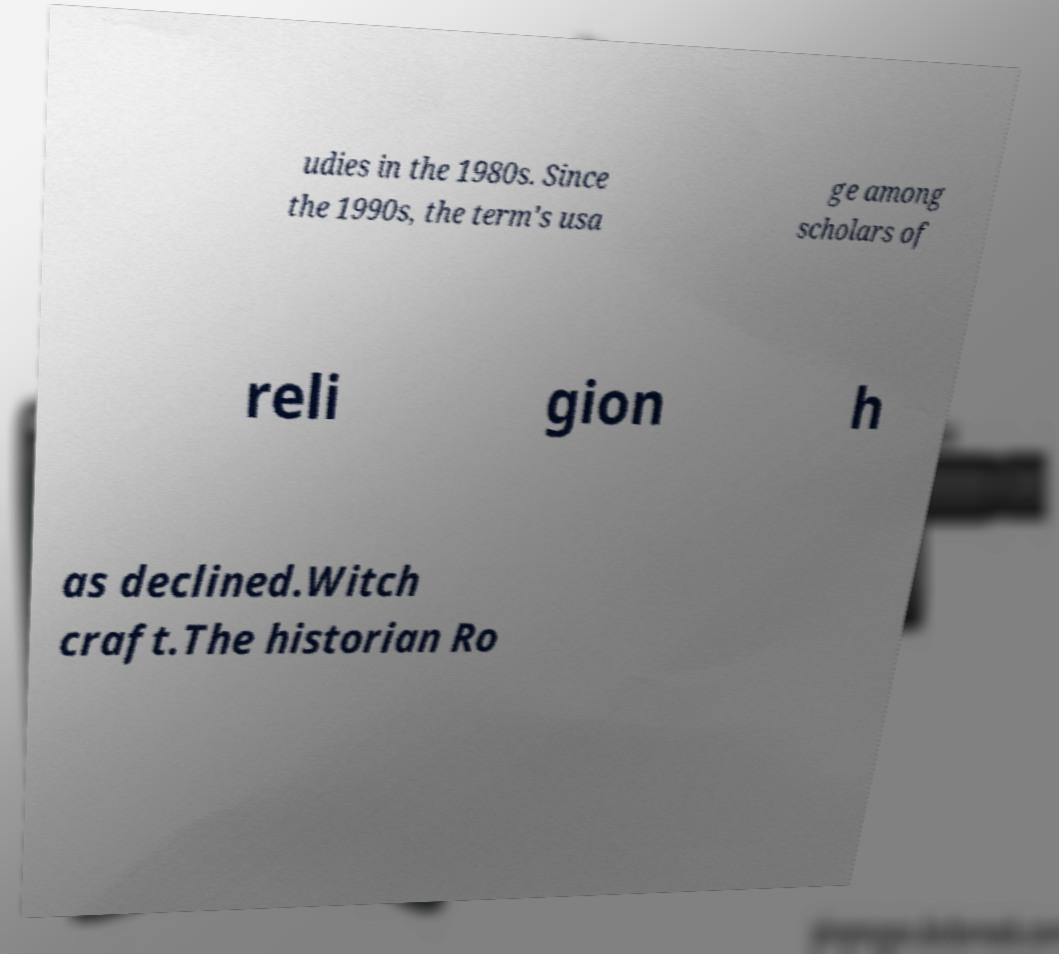Please identify and transcribe the text found in this image. udies in the 1980s. Since the 1990s, the term's usa ge among scholars of reli gion h as declined.Witch craft.The historian Ro 